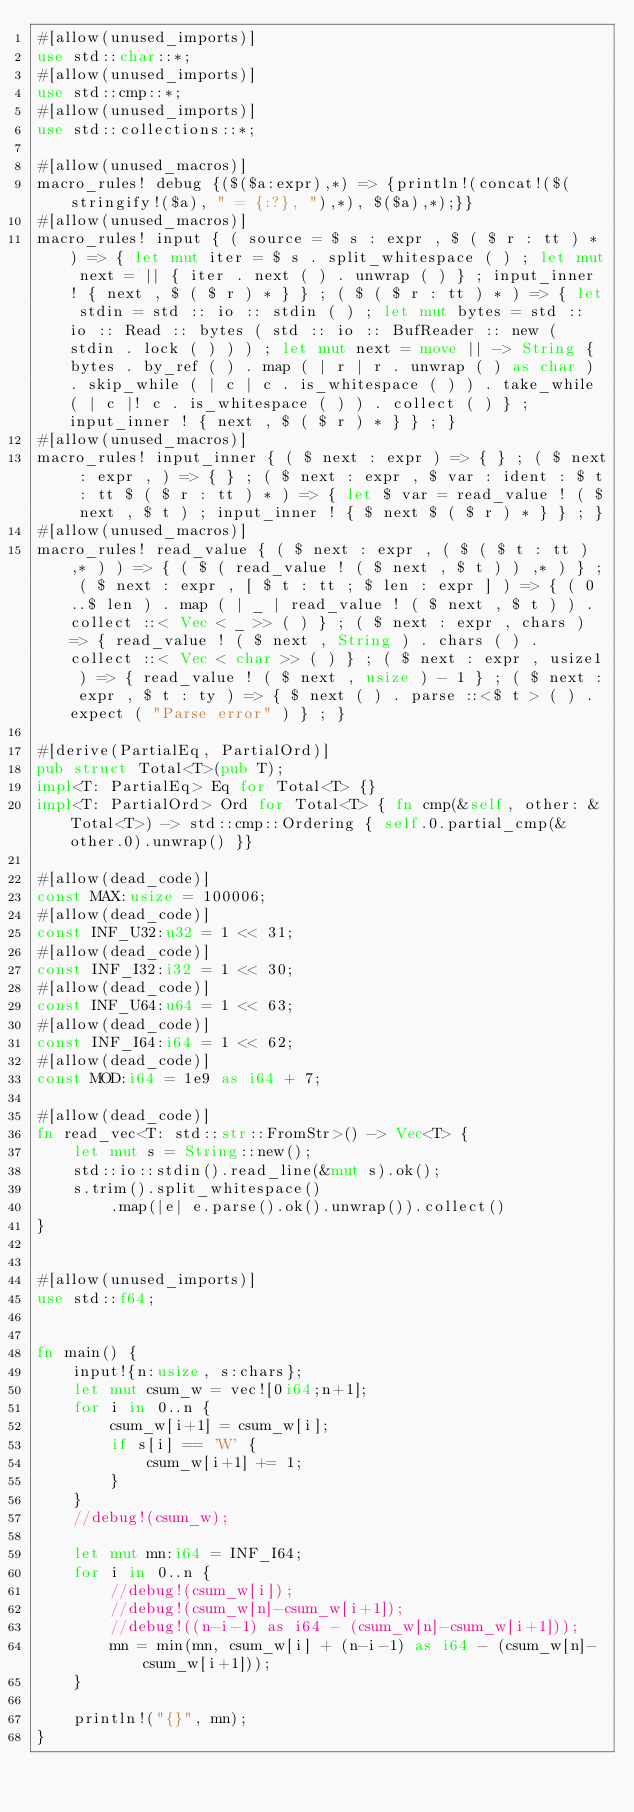Convert code to text. <code><loc_0><loc_0><loc_500><loc_500><_Rust_>#[allow(unused_imports)]
use std::char::*;
#[allow(unused_imports)]
use std::cmp::*;
#[allow(unused_imports)]
use std::collections::*;

#[allow(unused_macros)]
macro_rules! debug {($($a:expr),*) => {println!(concat!($(stringify!($a), " = {:?}, "),*), $($a),*);}}
#[allow(unused_macros)]
macro_rules! input { ( source = $ s : expr , $ ( $ r : tt ) * ) => { let mut iter = $ s . split_whitespace ( ) ; let mut next = || { iter . next ( ) . unwrap ( ) } ; input_inner ! { next , $ ( $ r ) * } } ; ( $ ( $ r : tt ) * ) => { let stdin = std :: io :: stdin ( ) ; let mut bytes = std :: io :: Read :: bytes ( std :: io :: BufReader :: new ( stdin . lock ( ) ) ) ; let mut next = move || -> String { bytes . by_ref ( ) . map ( | r | r . unwrap ( ) as char ) . skip_while ( | c | c . is_whitespace ( ) ) . take_while ( | c |! c . is_whitespace ( ) ) . collect ( ) } ; input_inner ! { next , $ ( $ r ) * } } ; }
#[allow(unused_macros)]
macro_rules! input_inner { ( $ next : expr ) => { } ; ( $ next : expr , ) => { } ; ( $ next : expr , $ var : ident : $ t : tt $ ( $ r : tt ) * ) => { let $ var = read_value ! ( $ next , $ t ) ; input_inner ! { $ next $ ( $ r ) * } } ; }
#[allow(unused_macros)]
macro_rules! read_value { ( $ next : expr , ( $ ( $ t : tt ) ,* ) ) => { ( $ ( read_value ! ( $ next , $ t ) ) ,* ) } ; ( $ next : expr , [ $ t : tt ; $ len : expr ] ) => { ( 0 ..$ len ) . map ( | _ | read_value ! ( $ next , $ t ) ) . collect ::< Vec < _ >> ( ) } ; ( $ next : expr , chars ) => { read_value ! ( $ next , String ) . chars ( ) . collect ::< Vec < char >> ( ) } ; ( $ next : expr , usize1 ) => { read_value ! ( $ next , usize ) - 1 } ; ( $ next : expr , $ t : ty ) => { $ next ( ) . parse ::<$ t > ( ) . expect ( "Parse error" ) } ; }

#[derive(PartialEq, PartialOrd)]
pub struct Total<T>(pub T);
impl<T: PartialEq> Eq for Total<T> {}
impl<T: PartialOrd> Ord for Total<T> { fn cmp(&self, other: &Total<T>) -> std::cmp::Ordering { self.0.partial_cmp(&other.0).unwrap() }}

#[allow(dead_code)]
const MAX:usize = 100006;
#[allow(dead_code)]
const INF_U32:u32 = 1 << 31;
#[allow(dead_code)]
const INF_I32:i32 = 1 << 30;
#[allow(dead_code)]
const INF_U64:u64 = 1 << 63;
#[allow(dead_code)]
const INF_I64:i64 = 1 << 62;
#[allow(dead_code)]
const MOD:i64 = 1e9 as i64 + 7;

#[allow(dead_code)]
fn read_vec<T: std::str::FromStr>() -> Vec<T> {
    let mut s = String::new();
    std::io::stdin().read_line(&mut s).ok();
    s.trim().split_whitespace()
        .map(|e| e.parse().ok().unwrap()).collect()
}


#[allow(unused_imports)]
use std::f64;


fn main() {
    input!{n:usize, s:chars};
    let mut csum_w = vec![0i64;n+1];
    for i in 0..n {
        csum_w[i+1] = csum_w[i];
        if s[i] == 'W' {
            csum_w[i+1] += 1;
        }
    }
    //debug!(csum_w);

    let mut mn:i64 = INF_I64;
    for i in 0..n {
        //debug!(csum_w[i]);
        //debug!(csum_w[n]-csum_w[i+1]);
        //debug!((n-i-1) as i64 - (csum_w[n]-csum_w[i+1]));
        mn = min(mn, csum_w[i] + (n-i-1) as i64 - (csum_w[n]-csum_w[i+1]));
    }

    println!("{}", mn);
}</code> 